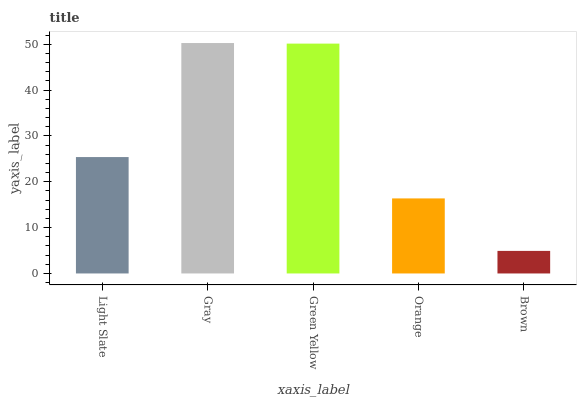Is Brown the minimum?
Answer yes or no. Yes. Is Gray the maximum?
Answer yes or no. Yes. Is Green Yellow the minimum?
Answer yes or no. No. Is Green Yellow the maximum?
Answer yes or no. No. Is Gray greater than Green Yellow?
Answer yes or no. Yes. Is Green Yellow less than Gray?
Answer yes or no. Yes. Is Green Yellow greater than Gray?
Answer yes or no. No. Is Gray less than Green Yellow?
Answer yes or no. No. Is Light Slate the high median?
Answer yes or no. Yes. Is Light Slate the low median?
Answer yes or no. Yes. Is Orange the high median?
Answer yes or no. No. Is Brown the low median?
Answer yes or no. No. 